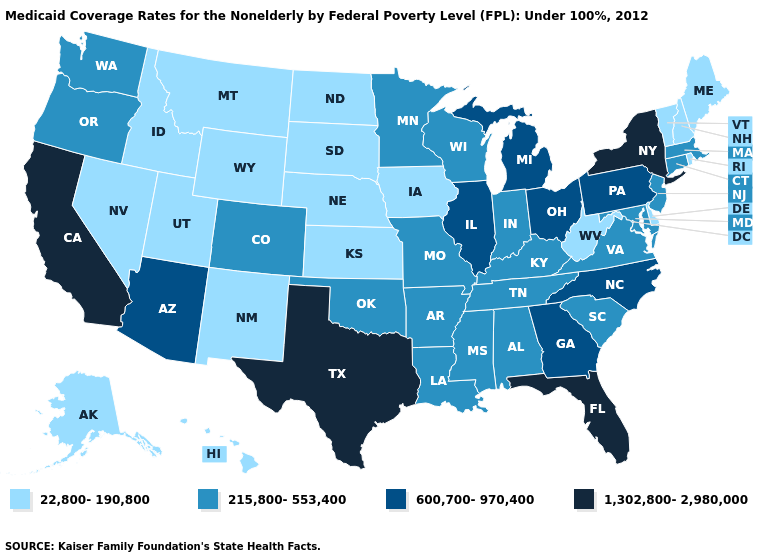Name the states that have a value in the range 1,302,800-2,980,000?
Keep it brief. California, Florida, New York, Texas. Is the legend a continuous bar?
Give a very brief answer. No. Does Alaska have the same value as Oklahoma?
Short answer required. No. What is the highest value in the South ?
Keep it brief. 1,302,800-2,980,000. What is the highest value in the West ?
Keep it brief. 1,302,800-2,980,000. How many symbols are there in the legend?
Be succinct. 4. Name the states that have a value in the range 22,800-190,800?
Give a very brief answer. Alaska, Delaware, Hawaii, Idaho, Iowa, Kansas, Maine, Montana, Nebraska, Nevada, New Hampshire, New Mexico, North Dakota, Rhode Island, South Dakota, Utah, Vermont, West Virginia, Wyoming. Which states hav the highest value in the Northeast?
Keep it brief. New York. Does New Mexico have the lowest value in the USA?
Quick response, please. Yes. Does Minnesota have a higher value than Illinois?
Quick response, please. No. Which states have the lowest value in the USA?
Keep it brief. Alaska, Delaware, Hawaii, Idaho, Iowa, Kansas, Maine, Montana, Nebraska, Nevada, New Hampshire, New Mexico, North Dakota, Rhode Island, South Dakota, Utah, Vermont, West Virginia, Wyoming. Name the states that have a value in the range 22,800-190,800?
Be succinct. Alaska, Delaware, Hawaii, Idaho, Iowa, Kansas, Maine, Montana, Nebraska, Nevada, New Hampshire, New Mexico, North Dakota, Rhode Island, South Dakota, Utah, Vermont, West Virginia, Wyoming. Name the states that have a value in the range 1,302,800-2,980,000?
Concise answer only. California, Florida, New York, Texas. What is the lowest value in the USA?
Concise answer only. 22,800-190,800. What is the highest value in states that border Pennsylvania?
Keep it brief. 1,302,800-2,980,000. 